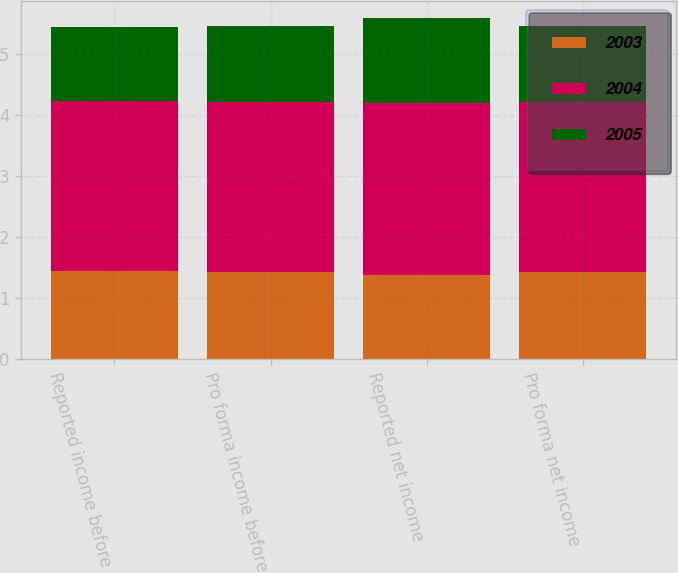<chart> <loc_0><loc_0><loc_500><loc_500><stacked_bar_chart><ecel><fcel>Reported income before<fcel>Pro forma income before<fcel>Reported net income<fcel>Pro forma net income<nl><fcel>2003<fcel>1.44<fcel>1.43<fcel>1.38<fcel>1.43<nl><fcel>2004<fcel>2.79<fcel>2.78<fcel>2.82<fcel>2.78<nl><fcel>2005<fcel>1.22<fcel>1.26<fcel>1.39<fcel>1.26<nl></chart> 